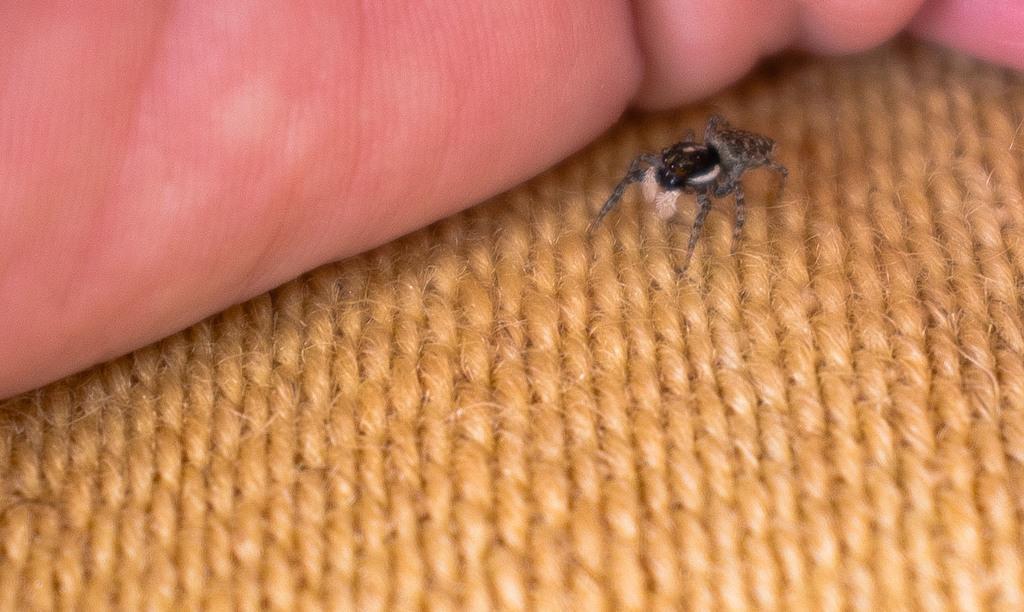In one or two sentences, can you explain what this image depicts? In this image I can see an insect which is in brown and gray color. Background I can see a human hand. 